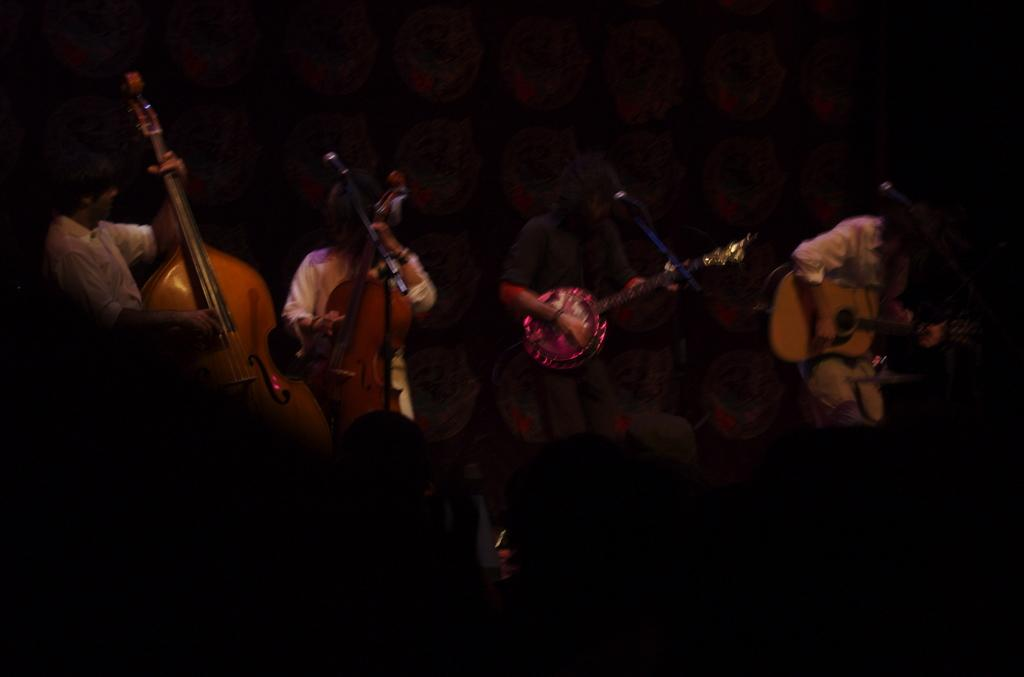What type of event is depicted in the image? The image is from a musical concert. How many people are in the image? There are four people in the image. What are the people holding in the image? Each person is holding a guitar. What are the people doing with the guitars? The people are playing the guitars. What type of rod can be seen in the image? There is no rod present in the image. What toys are the people playing with in the image? The people are not playing with toys in the image; they are playing guitars. 